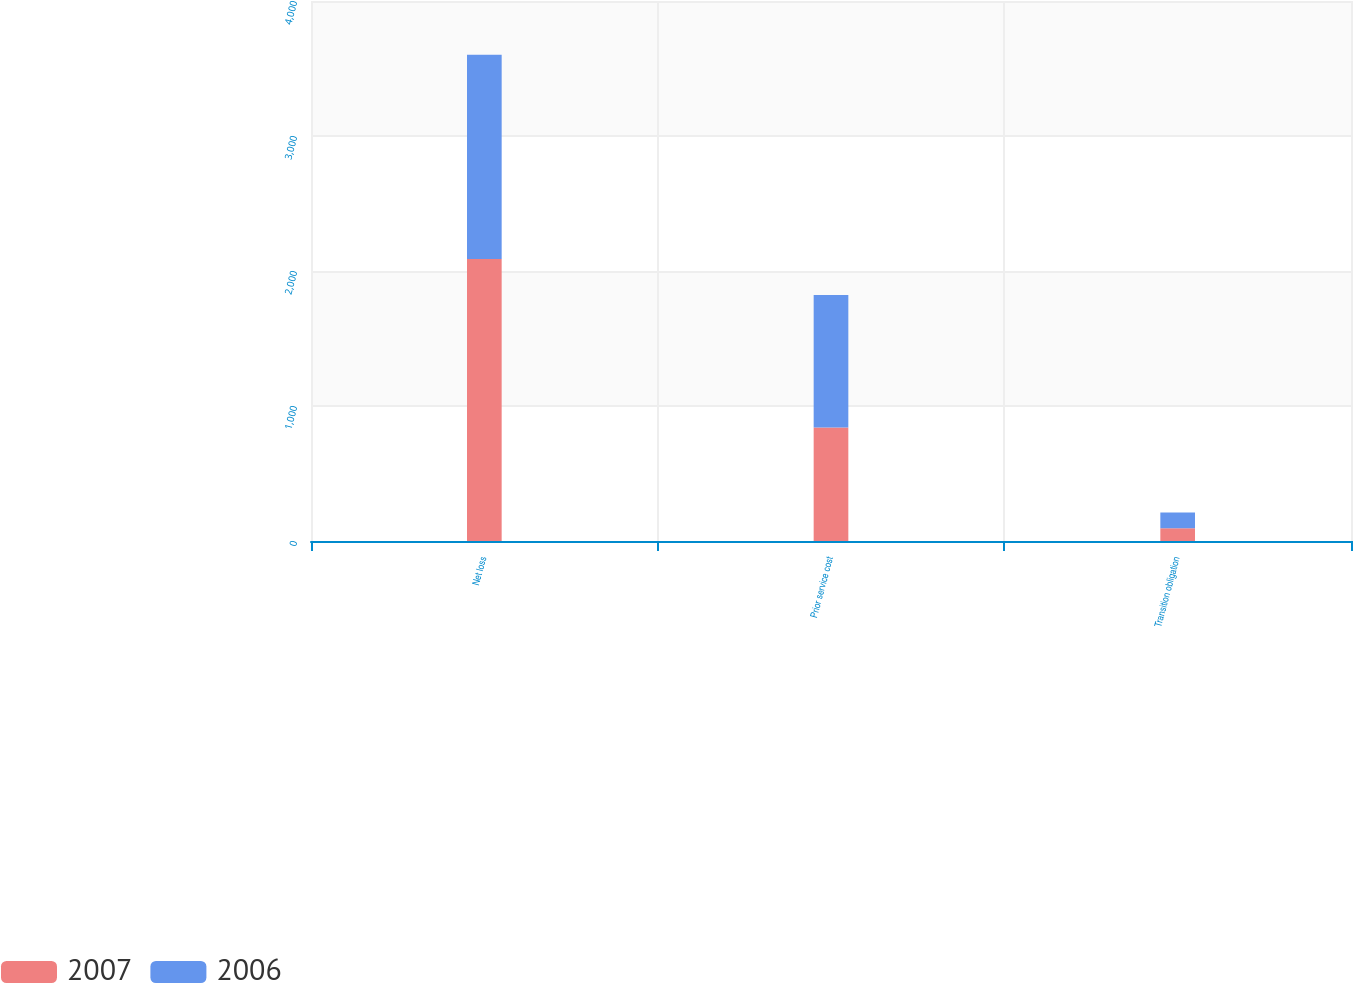<chart> <loc_0><loc_0><loc_500><loc_500><stacked_bar_chart><ecel><fcel>Net loss<fcel>Prior service cost<fcel>Transition obligation<nl><fcel>2007<fcel>2088<fcel>841<fcel>94<nl><fcel>2006<fcel>1514<fcel>982<fcel>117<nl></chart> 